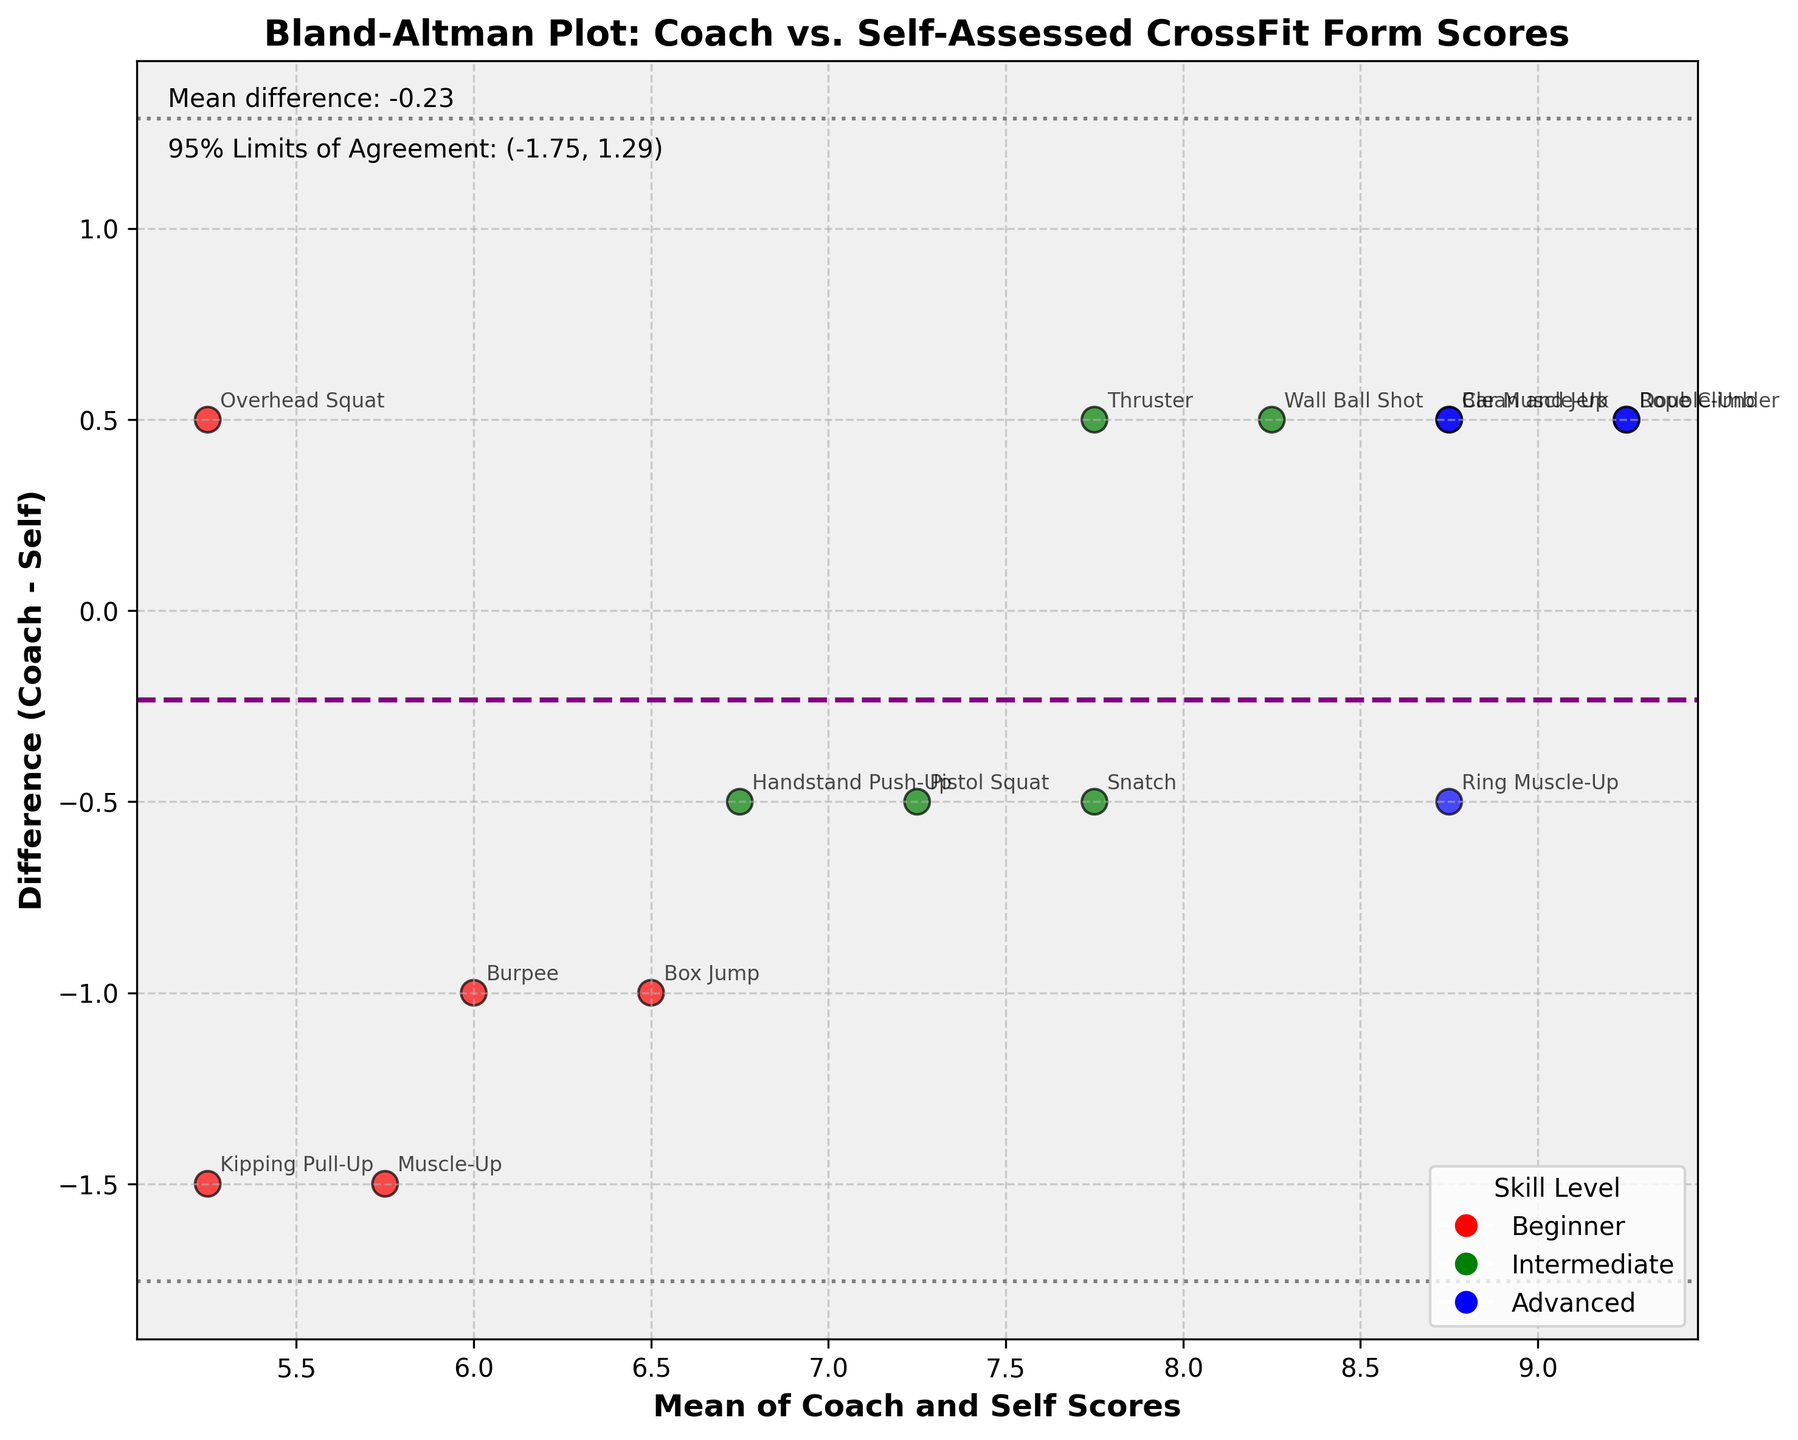How many data points are represented in the plot? Count the number of scatter points in the plot. Each point represents a data entry.
Answer: 15 What is the mean difference between coach and self-assessed scores? Look at the purple dashed line, which represents the mean difference. The value should be noted next to the line or stated within the plot text.
Answer: 0.18 Which skill level has the highest concentration of data points above the mean difference line? Identify the color representing each skill level and count how many points of each color are above the purple dashed line.
Answer: Beginner What are the 95% limits of agreement for the differences between coach and self-assessed scores? Look at the horizontal dotted lines; the values are typically noted next to these lines within the plot.
Answer: (-0.92, 1.28) Which movement has the largest difference between coach and self-assessed scores? Check the vertical distance on the y-axis for each point from the mean difference line (purple dashed line) and note the largest difference either positively or negatively.
Answer: Jessica Lee, Kipping Pull-Up Which two skill levels have the closest mean of the combined coach and self-assessed form scores? Look at the x-axis to see where the mean scores are closest for each skill level color. Compare data points and mention the skill levels with closest mean scores.
Answer: Advanced and Intermediate What is the difference in scores for Michael Brown's Muscle-Up? Identify Michael Brown's Muscle-Up point (normally labeled if annotated), then read the y-axis value for its vertical position.
Answer: -1.5 Which skill level had the smallest variation in score differences? Observe the spread (density) of points for each color and determine which color has the least spread from the mean difference line (purple line).
Answer: Advanced What does a negative score difference indicate in this plot? The y-axis represents the difference between coach and self scores, with negative values indicating coach scores are lower than self scores.
Answer: Coach scores are lower than self scores Which movement had a perfect agreement between coach and self-assessed scores? Look for a point that lies exactly on the y-axis value of 0, where the coach and self scores are equal.
Answer: Chris Anderson, Overhead Squat 